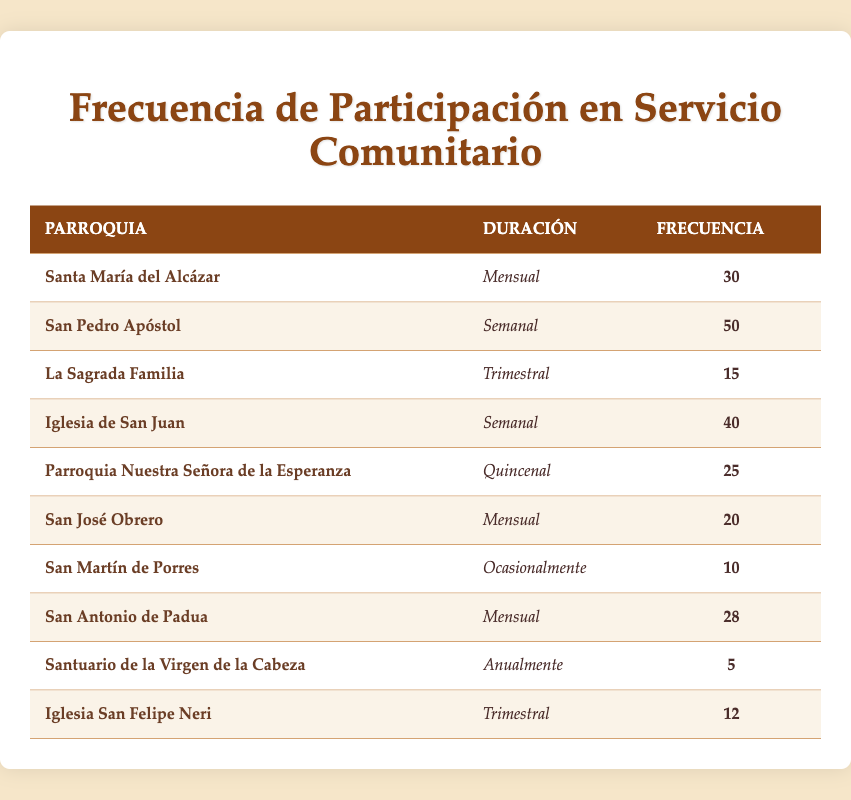What is the frequency of participation for San Pedro Apóstol? The table shows that San Pedro Apóstol has a frequency of 50 participants.
Answer: 50 How many parishes have a monthly frequency of participation? By checking the table, there are three parishes with "Monthly" duration: Santa María del Alcázar (30), San José Obrero (20), and San Antonio de Padua (28), which gives a total of 3 parishes.
Answer: 3 What is the total frequency of participation among all parishes? To find the total, sum the frequencies: 30 + 50 + 15 + 40 + 25 + 20 + 10 + 28 + 5 + 12 =  235.
Answer: 235 Is the frequency of participation for San Martín de Porres higher than that for Iglesia San Felipe Neri? San Martín de Porres has a frequency of 10, while Iglesia San Felipe Neri has a frequency of 12. Thus, 10 is not greater than 12.
Answer: No Which parish has the highest frequency of community service participation? Upon examining the table, San Pedro Apóstol has the highest frequency at 50 participants, more than any other parish.
Answer: San Pedro Apóstol 